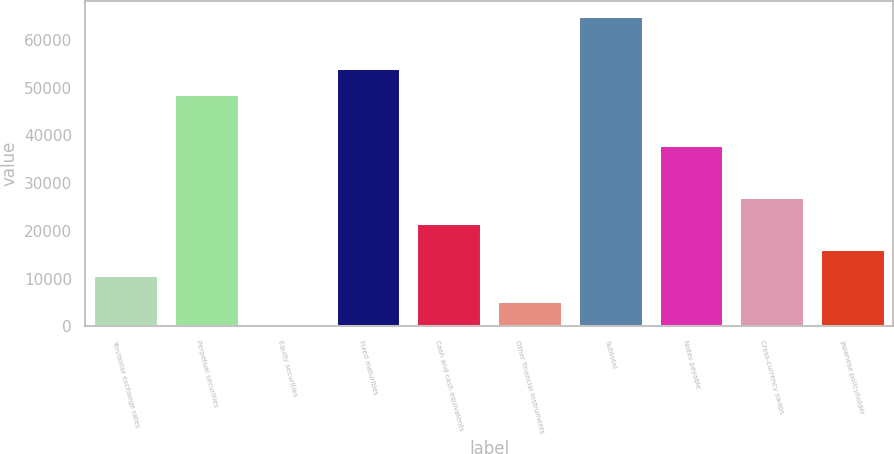<chart> <loc_0><loc_0><loc_500><loc_500><bar_chart><fcel>Yen/dollar exchange rates<fcel>Perpetual securities<fcel>Equity securities<fcel>Fixed maturities<fcel>Cash and cash equivalents<fcel>Other financial instruments<fcel>Subtotal<fcel>Notes payable<fcel>Cross-currency swaps<fcel>Japanese policyholder<nl><fcel>10837.8<fcel>48703.6<fcel>19<fcel>54113<fcel>21656.6<fcel>5428.4<fcel>64931.8<fcel>37884.8<fcel>27066<fcel>16247.2<nl></chart> 